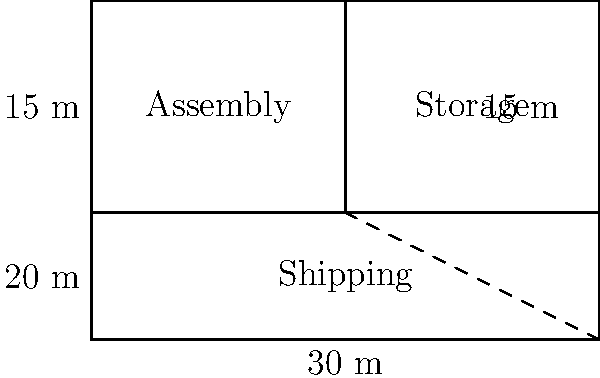As a union representative, you've been asked to calculate the total area of the factory floor to ensure proper space allocation for workers. The factory floor plan is divided into three sections: Assembly, Storage, and Shipping. The Shipping area is a right triangle. Given the dimensions shown in the diagram, what is the total area of the factory floor in square meters? Let's calculate the area step by step:

1. Calculate the area of the Assembly section:
   $A_{assembly} = 15 \text{ m} \times 20 \text{ m} = 300 \text{ m}^2$

2. Calculate the area of the Storage section:
   $A_{storage} = 15 \text{ m} \times 15 \text{ m} = 225 \text{ m}^2$

3. Calculate the area of the Shipping section (right triangle):
   Base = 30 m, Height = 20 m
   $A_{shipping} = \frac{1}{2} \times 30 \text{ m} \times 20 \text{ m} = 300 \text{ m}^2$

4. Sum up all areas to get the total factory floor area:
   $A_{total} = A_{assembly} + A_{storage} + A_{shipping}$
   $A_{total} = 300 \text{ m}^2 + 225 \text{ m}^2 + 300 \text{ m}^2 = 825 \text{ m}^2$

Therefore, the total area of the factory floor is 825 square meters.
Answer: 825 m² 